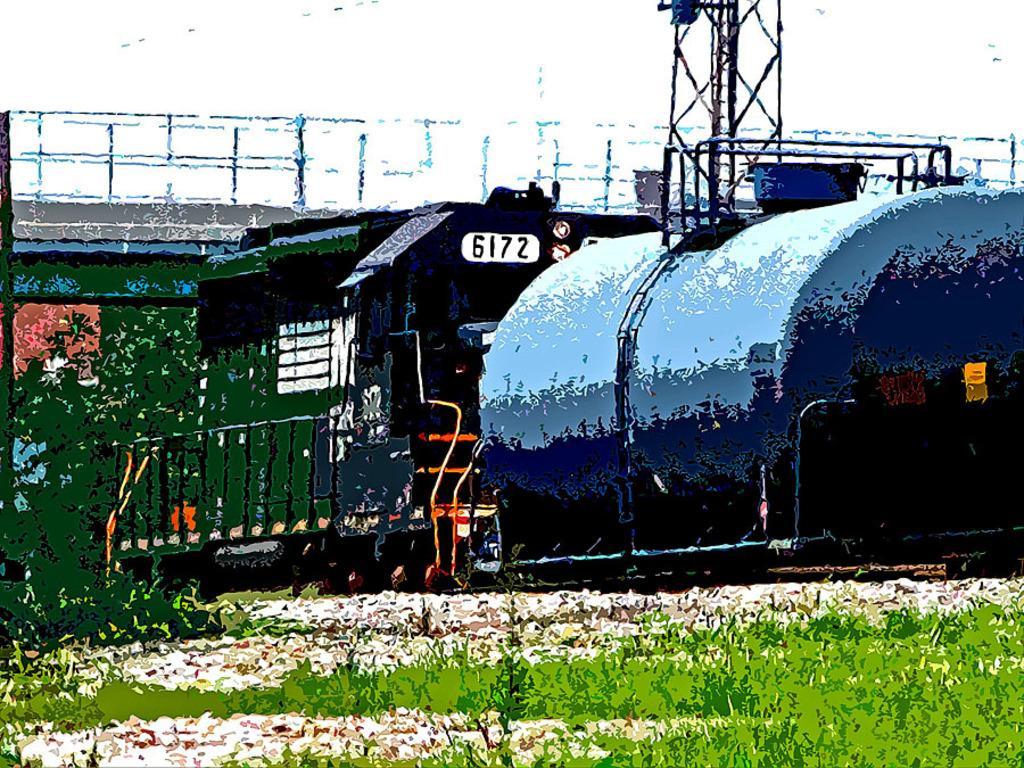Describe this image in one or two sentences. This image is an edited image. This image is taken outdoors. At the bottom of the image there is grass on the ground. In the background there is a bridge. There are a few iron and there is a tower. In the middle of the image there is an engine of a train. 